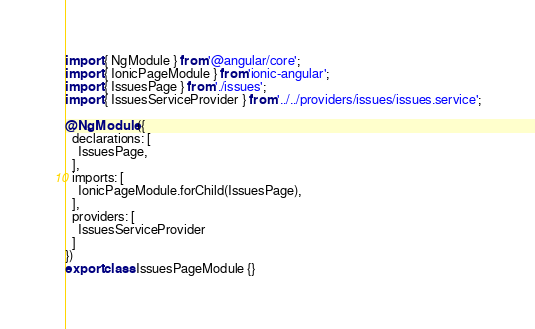Convert code to text. <code><loc_0><loc_0><loc_500><loc_500><_TypeScript_>import { NgModule } from '@angular/core';
import { IonicPageModule } from 'ionic-angular';
import { IssuesPage } from './issues';
import { IssuesServiceProvider } from '../../providers/issues/issues.service';

@NgModule({
  declarations: [
    IssuesPage,
  ],
  imports: [
    IonicPageModule.forChild(IssuesPage),
  ],
  providers: [
    IssuesServiceProvider
  ]
})
export class IssuesPageModule {}
</code> 